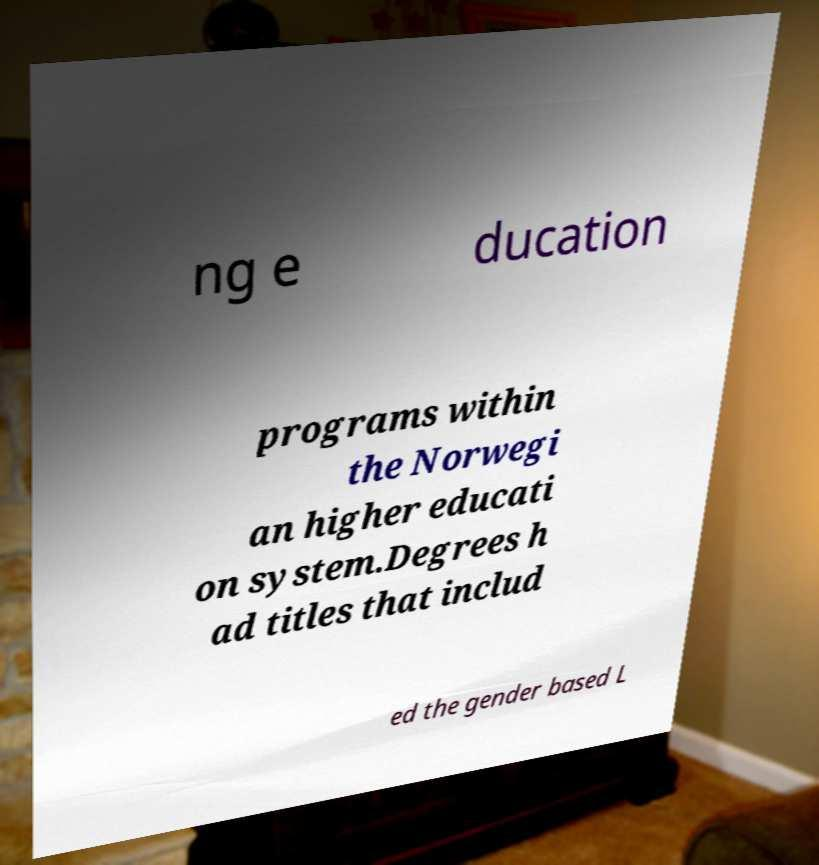Could you assist in decoding the text presented in this image and type it out clearly? ng e ducation programs within the Norwegi an higher educati on system.Degrees h ad titles that includ ed the gender based L 